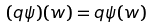Convert formula to latex. <formula><loc_0><loc_0><loc_500><loc_500>( q \psi ) ( w ) = q \psi ( w )</formula> 